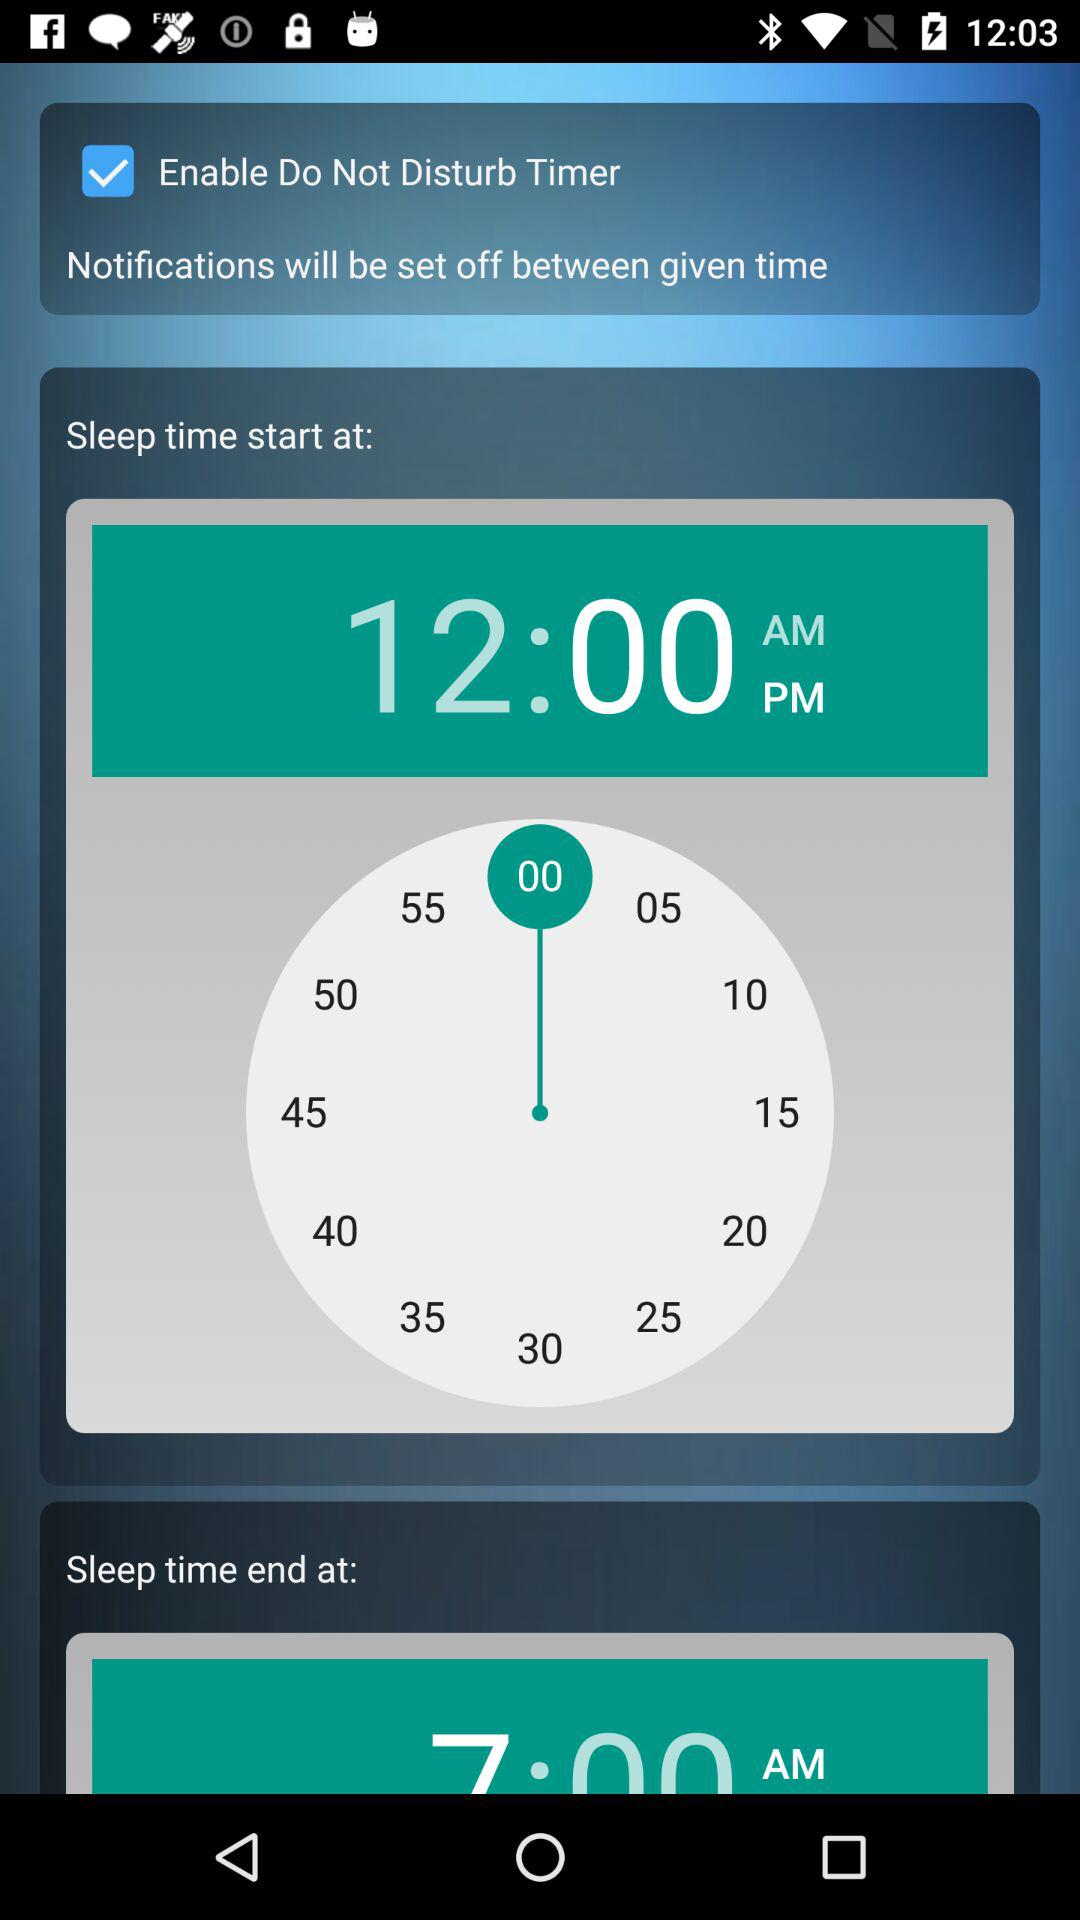At what time does sleep time start? Sleep time starts at 12:00 PM. 